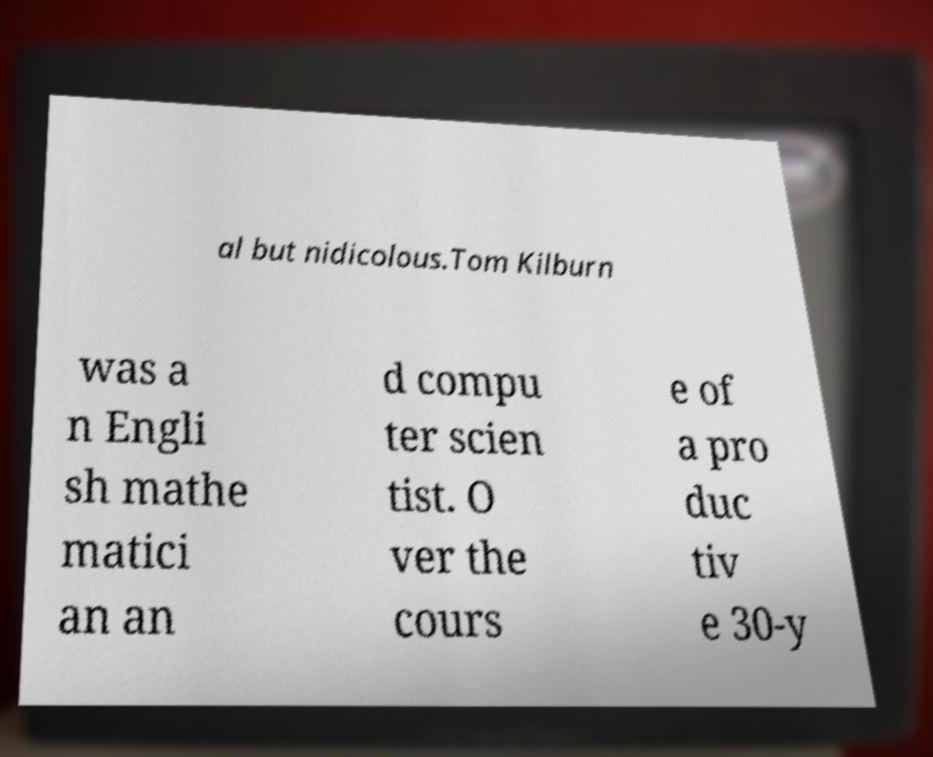What messages or text are displayed in this image? I need them in a readable, typed format. al but nidicolous.Tom Kilburn was a n Engli sh mathe matici an an d compu ter scien tist. O ver the cours e of a pro duc tiv e 30-y 